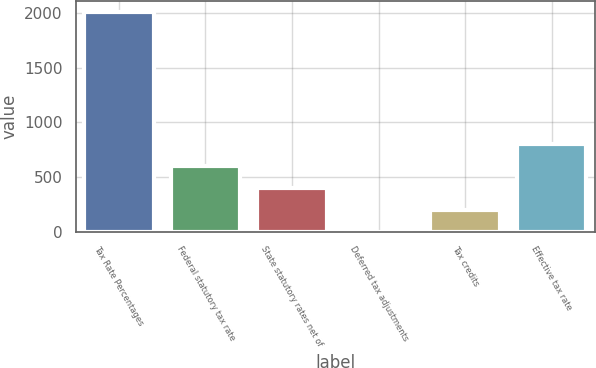Convert chart to OTSL. <chart><loc_0><loc_0><loc_500><loc_500><bar_chart><fcel>Tax Rate Percentages<fcel>Federal statutory tax rate<fcel>State statutory rates net of<fcel>Deferred tax adjustments<fcel>Tax credits<fcel>Effective tax rate<nl><fcel>2006<fcel>602.15<fcel>401.6<fcel>0.5<fcel>201.05<fcel>802.7<nl></chart> 